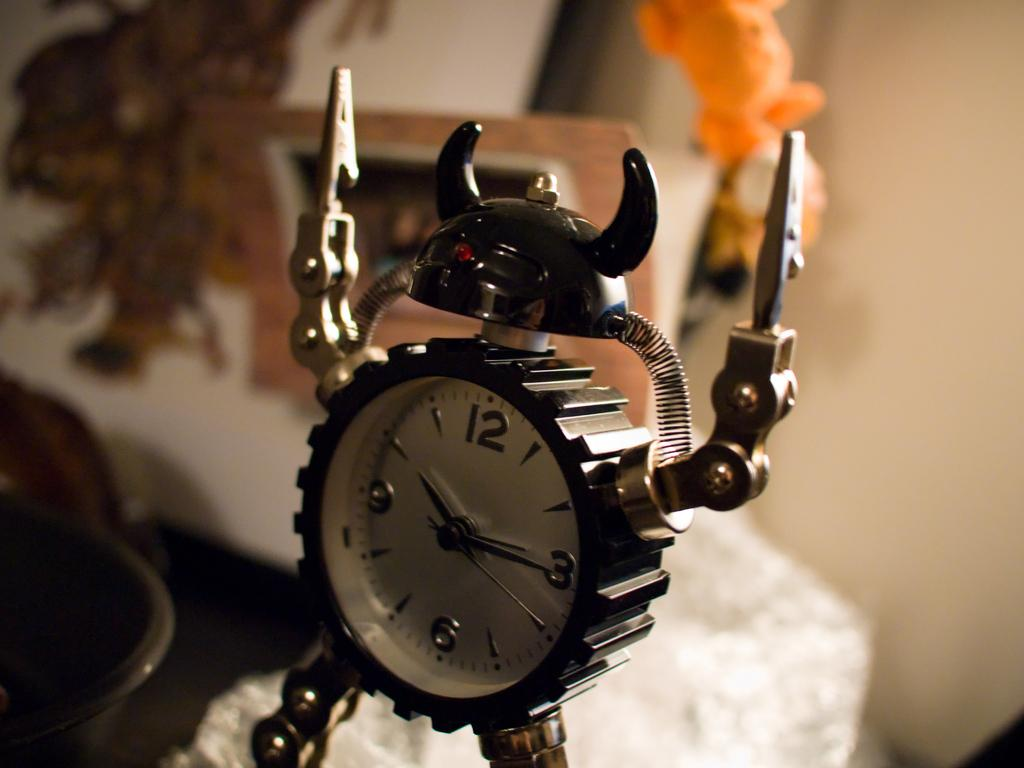<image>
Create a compact narrative representing the image presented. An alarm clock at 10:16 shaped like a warrior. 